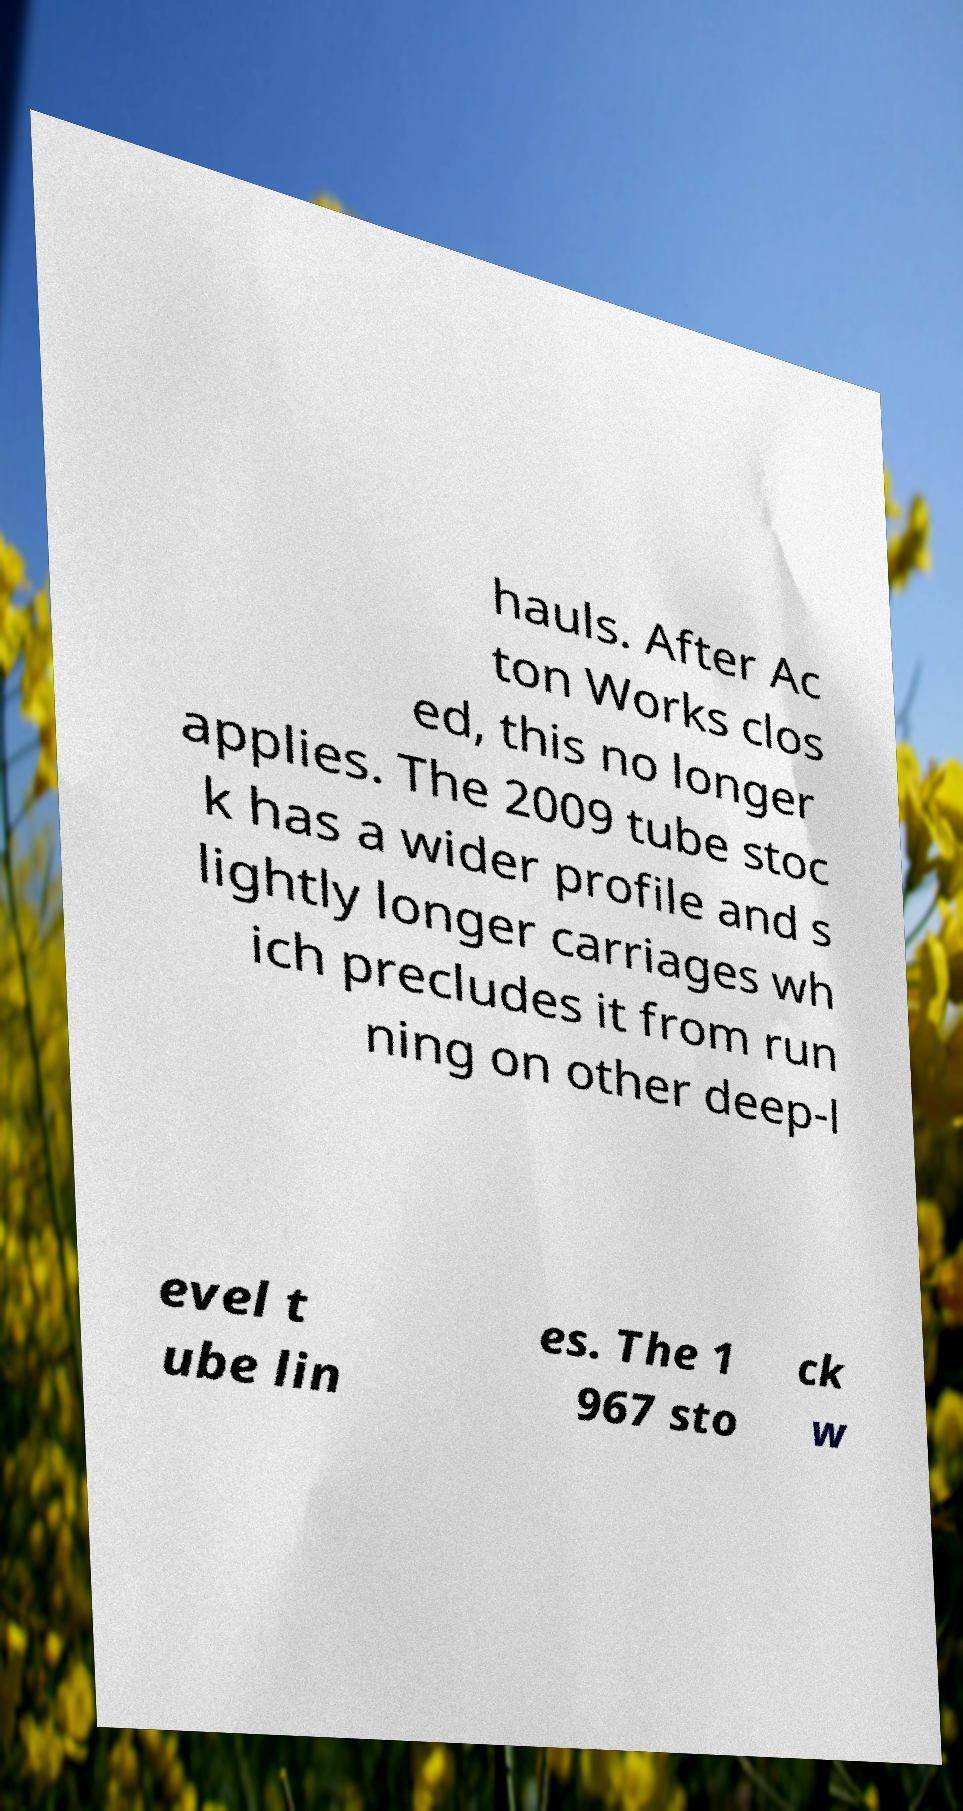There's text embedded in this image that I need extracted. Can you transcribe it verbatim? hauls. After Ac ton Works clos ed, this no longer applies. The 2009 tube stoc k has a wider profile and s lightly longer carriages wh ich precludes it from run ning on other deep-l evel t ube lin es. The 1 967 sto ck w 